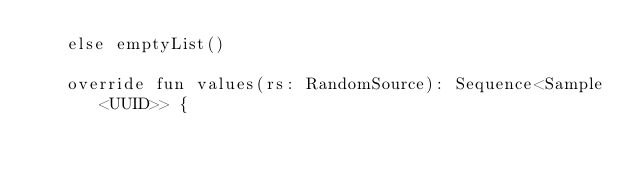Convert code to text. <code><loc_0><loc_0><loc_500><loc_500><_Kotlin_>   else emptyList()

   override fun values(rs: RandomSource): Sequence<Sample<UUID>> {</code> 